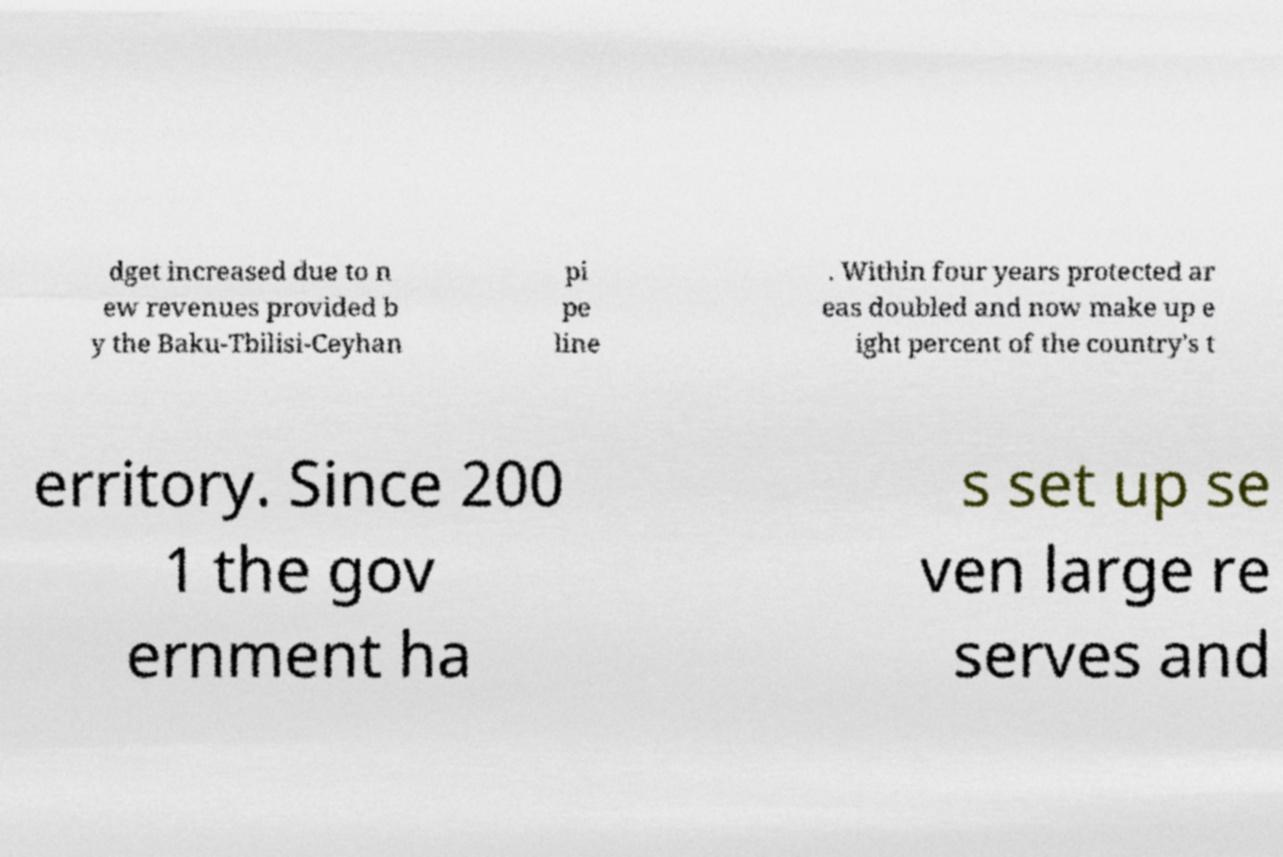Could you assist in decoding the text presented in this image and type it out clearly? dget increased due to n ew revenues provided b y the Baku-Tbilisi-Ceyhan pi pe line . Within four years protected ar eas doubled and now make up e ight percent of the country's t erritory. Since 200 1 the gov ernment ha s set up se ven large re serves and 